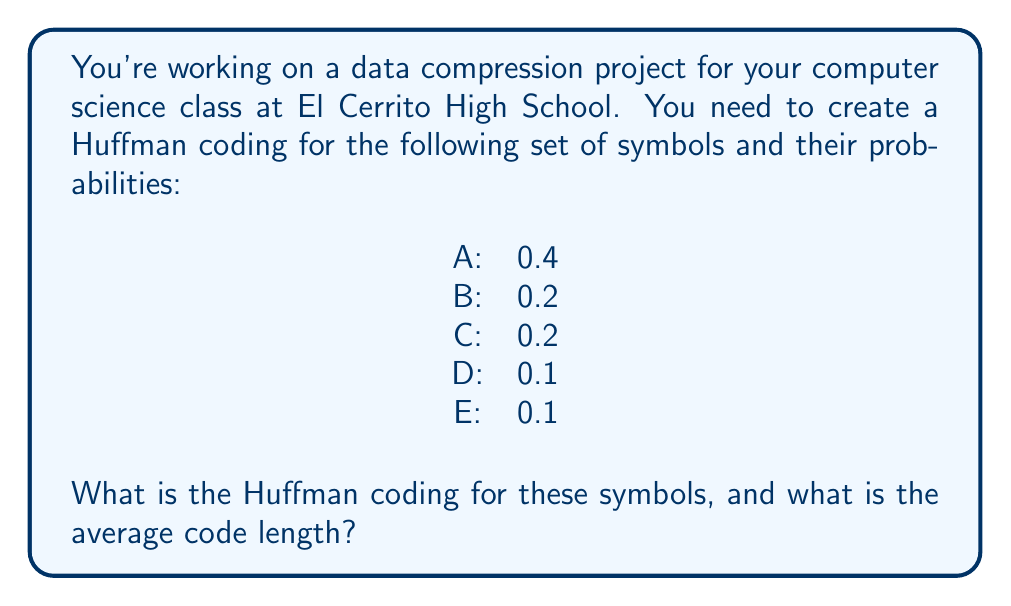Solve this math problem. Let's go through the Huffman coding algorithm step by step:

1) First, we order the symbols by their probabilities:
   A: 0.4, B: 0.2, C: 0.2, D: 0.1, E: 0.1

2) We start by combining the two least probable symbols (D and E):
   A: 0.4, B: 0.2, C: 0.2, DE: 0.2

3) We repeat this process:
   A: 0.4, BC: 0.4, DE: 0.2

4) Again:
   A: 0.4, BCDE: 0.6

5) Finally:
   ABCDE: 1.0

Now we can assign the codes, starting from the root and moving down, assigning 0 to one branch and 1 to the other:

```
       ABCDE (1.0)
      0/     \1
     A        BCDE (0.6)
            0/      \1
           BC        DE (0.2)
         0/  \1    0/   \1
        B     C   D     E
```

Therefore, the Huffman codes are:
A: 0
B: 10
C: 11
D: 110
E: 111

To calculate the average code length, we multiply each code length by its probability and sum:

$$ \text{Average Length} = (1 \cdot 0.4) + (2 \cdot 0.2) + (2 \cdot 0.2) + (3 \cdot 0.1) + (3 \cdot 0.1) $$
$$ = 0.4 + 0.4 + 0.4 + 0.3 + 0.3 = 1.8 \text{ bits} $$
Answer: Huffman codes:
A: 0
B: 10
C: 11
D: 110
E: 111

Average code length: 1.8 bits 